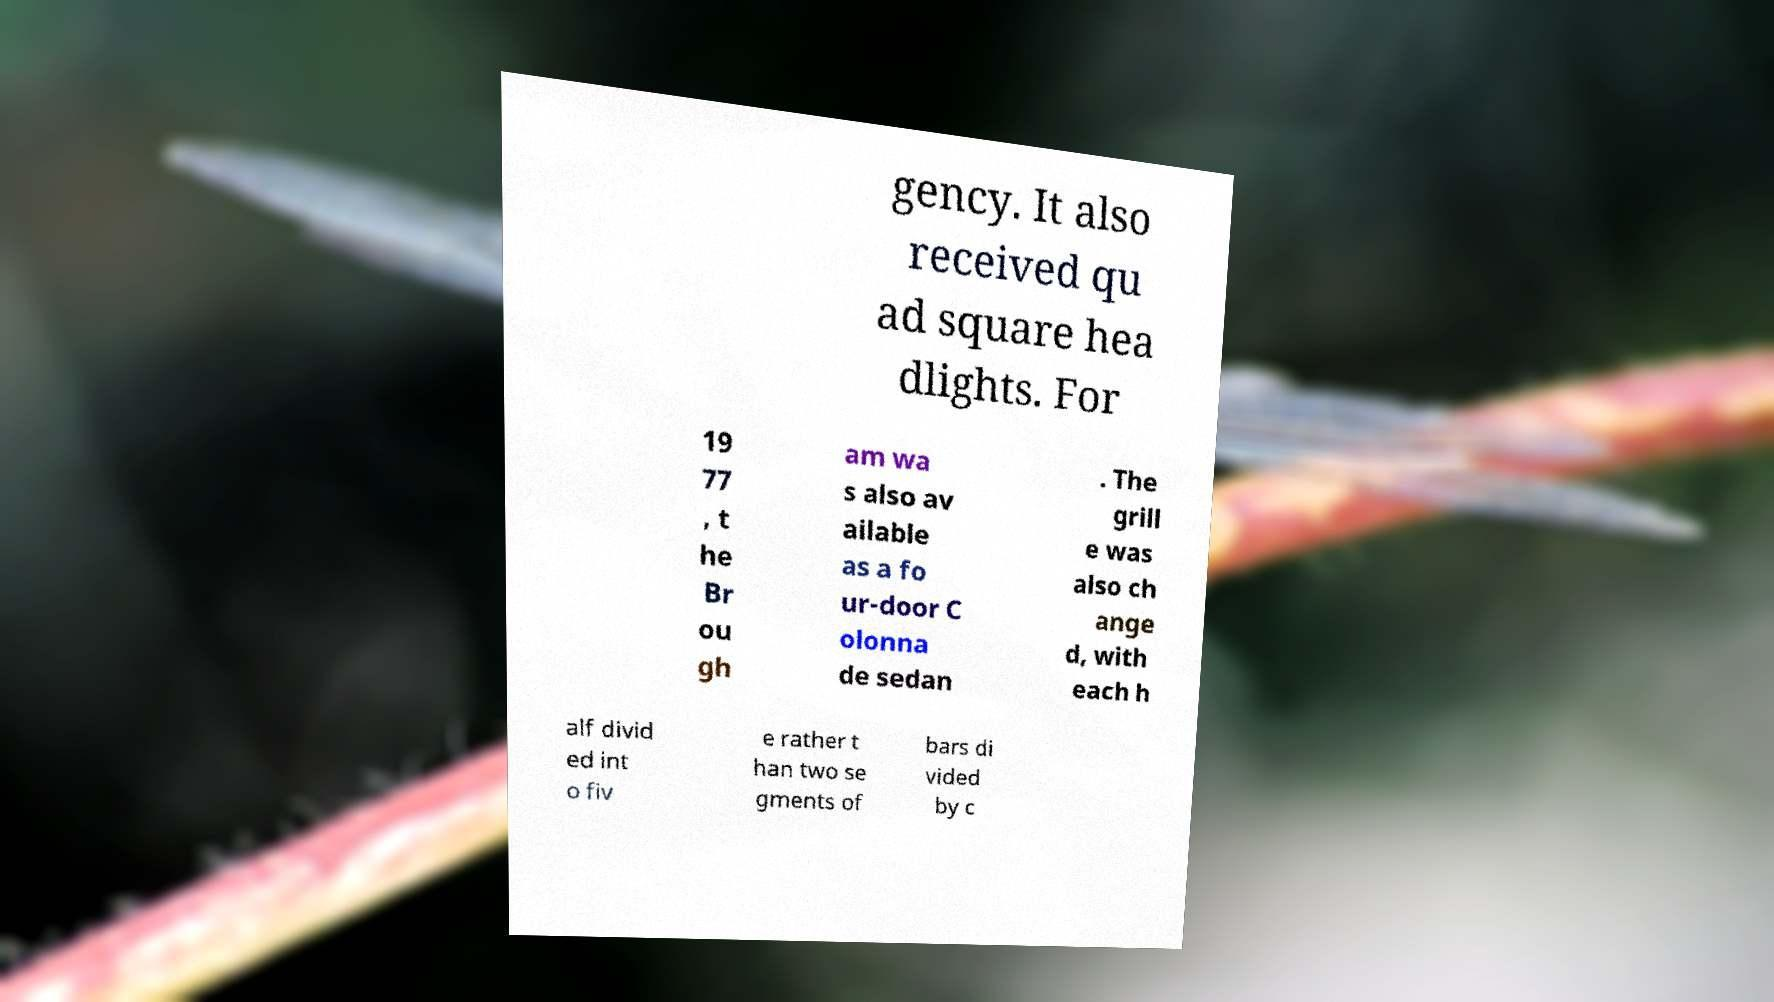Could you extract and type out the text from this image? gency. It also received qu ad square hea dlights. For 19 77 , t he Br ou gh am wa s also av ailable as a fo ur-door C olonna de sedan . The grill e was also ch ange d, with each h alf divid ed int o fiv e rather t han two se gments of bars di vided by c 